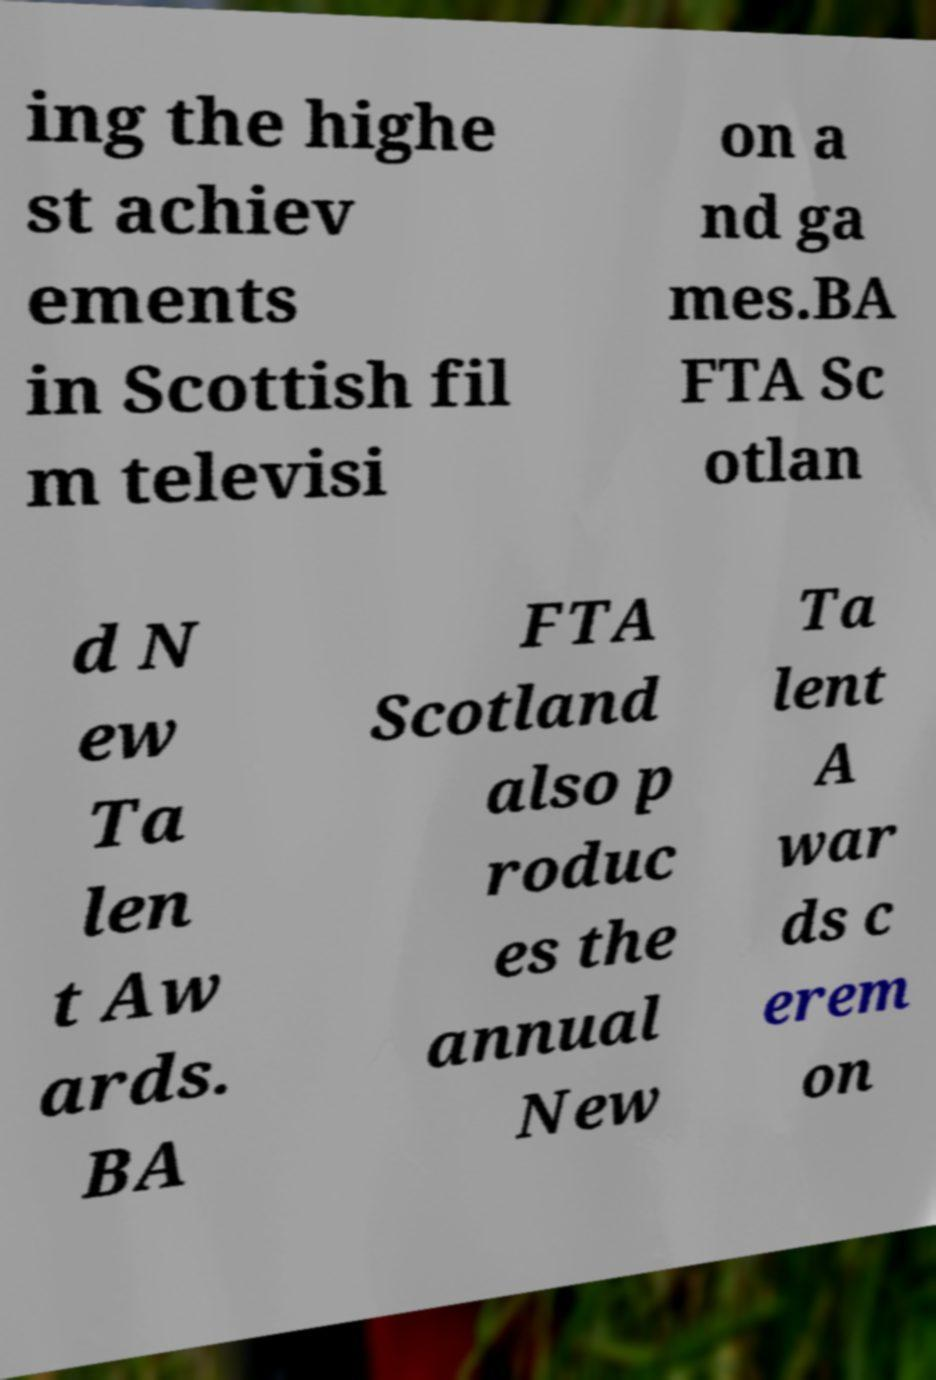Can you read and provide the text displayed in the image?This photo seems to have some interesting text. Can you extract and type it out for me? ing the highe st achiev ements in Scottish fil m televisi on a nd ga mes.BA FTA Sc otlan d N ew Ta len t Aw ards. BA FTA Scotland also p roduc es the annual New Ta lent A war ds c erem on 